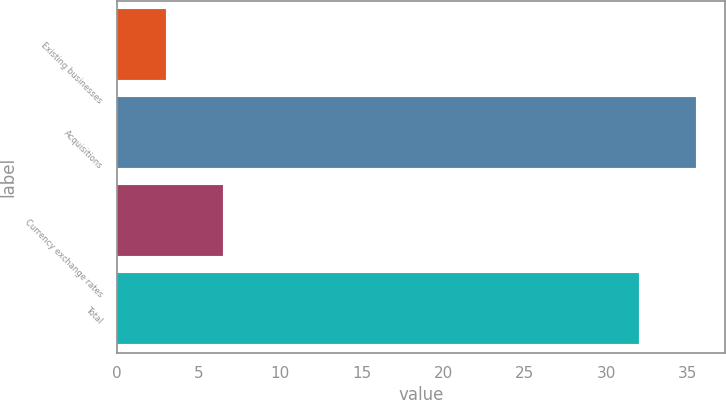<chart> <loc_0><loc_0><loc_500><loc_500><bar_chart><fcel>Existing businesses<fcel>Acquisitions<fcel>Currency exchange rates<fcel>Total<nl><fcel>3<fcel>35.5<fcel>6.5<fcel>32<nl></chart> 